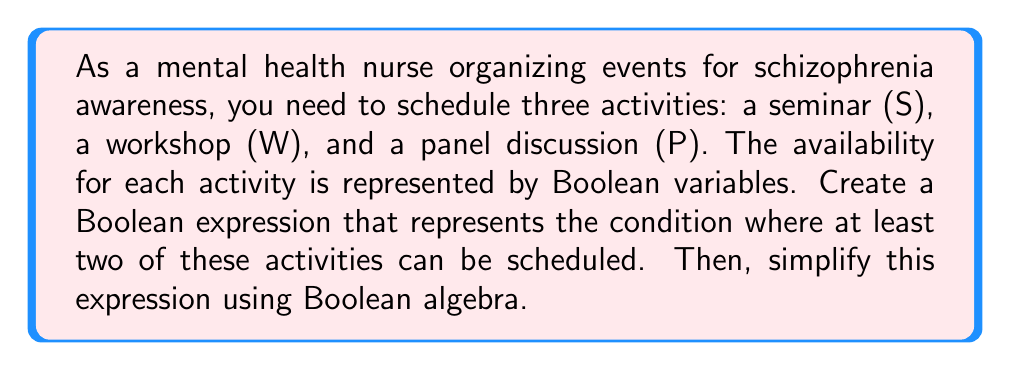Show me your answer to this math problem. Let's approach this step-by-step:

1) First, we need to create a Boolean expression for "at least two activities can be scheduled". This can be represented as:

   $$(S \wedge W) \vee (S \wedge P) \vee (W \wedge P)$$

   Where $\wedge$ represents AND, and $\vee$ represents OR.

2) Now, let's simplify this expression using Boolean algebra laws:

   $$(S \wedge W) \vee (S \wedge P) \vee (W \wedge P)$$

3) We can factor out S from the first two terms:

   $$S(W \vee P) \vee (W \wedge P)$$

4) Now, we can apply the distributive law:

   $$(S \wedge W) \vee (S \wedge P) \vee (W \wedge P)$$

5) This is our simplified expression. It means that either S and W are scheduled, or S and P are scheduled, or W and P are scheduled.

6) We can verify that this expression indeed represents "at least two activities":
   - If all three are scheduled (S = W = P = 1), the expression is true.
   - If any two are scheduled (e.g., S = W = 1, P = 0), the expression is true.
   - If only one or none are scheduled, the expression is false.

Thus, this Boolean expression optimally represents the scheduling condition for the schizophrenia awareness events.
Answer: $$(S \wedge W) \vee (S \wedge P) \vee (W \wedge P)$$ 